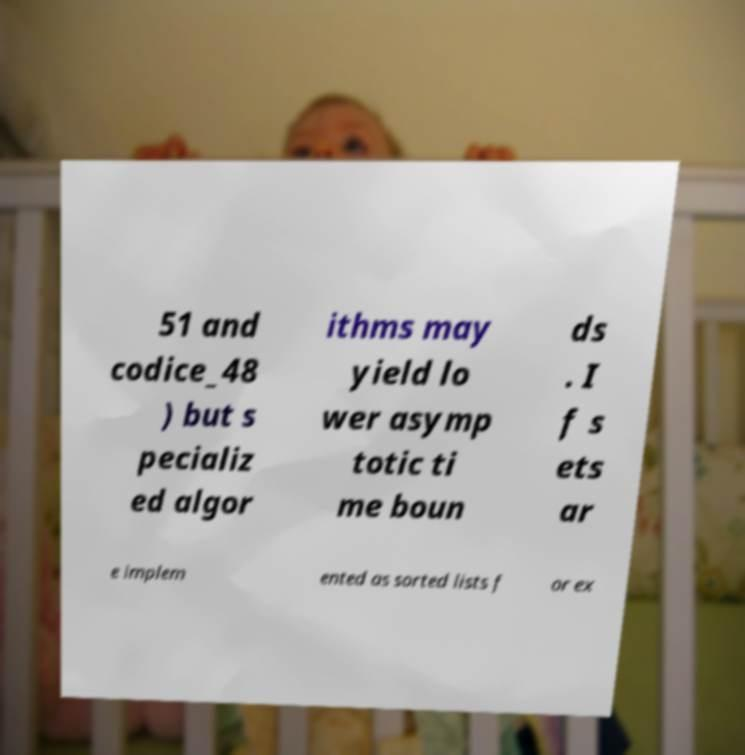For documentation purposes, I need the text within this image transcribed. Could you provide that? 51 and codice_48 ) but s pecializ ed algor ithms may yield lo wer asymp totic ti me boun ds . I f s ets ar e implem ented as sorted lists f or ex 